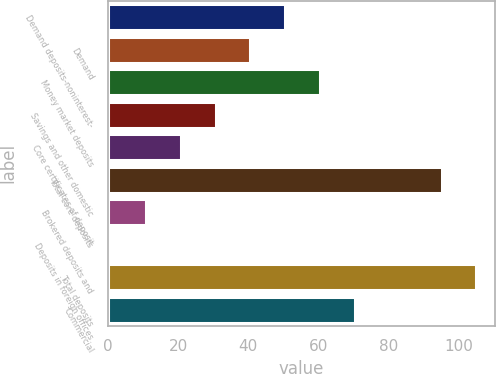Convert chart. <chart><loc_0><loc_0><loc_500><loc_500><bar_chart><fcel>Demand deposits-noninterest-<fcel>Demand<fcel>Money market deposits<fcel>Savings and other domestic<fcel>Core certificates of deposit<fcel>Total core deposits<fcel>Brokered deposits and<fcel>Deposits in foreign offices<fcel>Total deposits<fcel>Commercial<nl><fcel>50.5<fcel>40.6<fcel>60.4<fcel>30.7<fcel>20.8<fcel>95<fcel>10.9<fcel>1<fcel>104.9<fcel>70.3<nl></chart> 